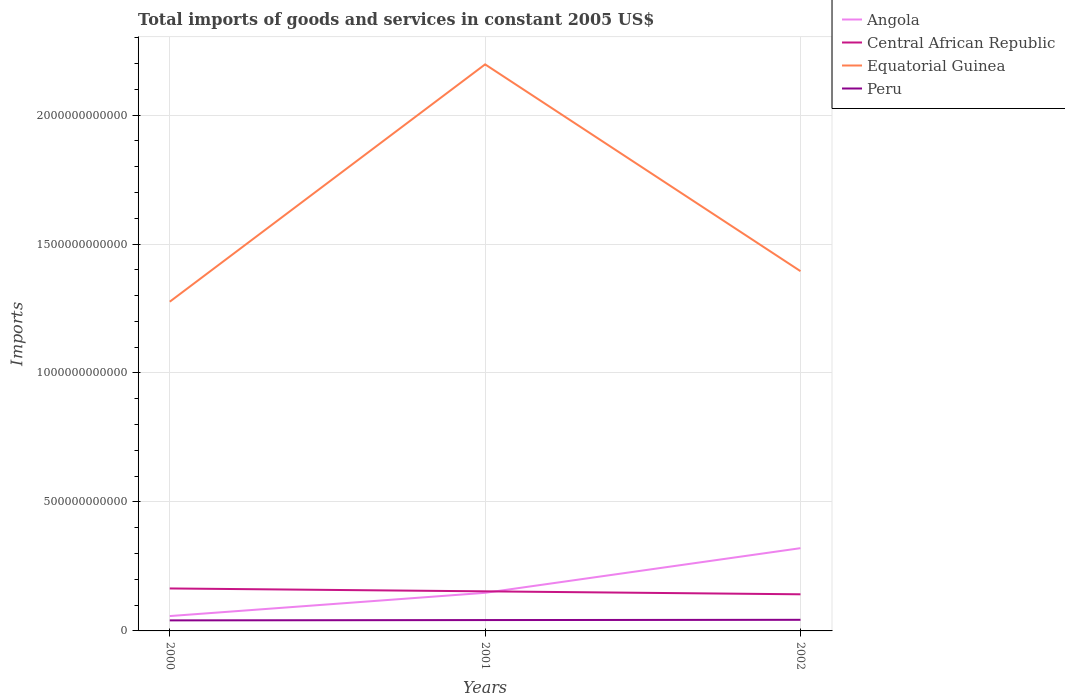How many different coloured lines are there?
Offer a very short reply. 4. Does the line corresponding to Angola intersect with the line corresponding to Equatorial Guinea?
Offer a very short reply. No. Across all years, what is the maximum total imports of goods and services in Peru?
Provide a short and direct response. 4.09e+1. In which year was the total imports of goods and services in Equatorial Guinea maximum?
Keep it short and to the point. 2000. What is the total total imports of goods and services in Central African Republic in the graph?
Your response must be concise. 1.15e+1. What is the difference between the highest and the second highest total imports of goods and services in Angola?
Your answer should be compact. 2.63e+11. Is the total imports of goods and services in Equatorial Guinea strictly greater than the total imports of goods and services in Peru over the years?
Ensure brevity in your answer.  No. How many lines are there?
Your answer should be very brief. 4. How many years are there in the graph?
Your response must be concise. 3. What is the difference between two consecutive major ticks on the Y-axis?
Your response must be concise. 5.00e+11. Are the values on the major ticks of Y-axis written in scientific E-notation?
Your answer should be compact. No. Where does the legend appear in the graph?
Your answer should be compact. Top right. How many legend labels are there?
Offer a very short reply. 4. What is the title of the graph?
Your answer should be compact. Total imports of goods and services in constant 2005 US$. Does "American Samoa" appear as one of the legend labels in the graph?
Ensure brevity in your answer.  No. What is the label or title of the X-axis?
Offer a very short reply. Years. What is the label or title of the Y-axis?
Your response must be concise. Imports. What is the Imports of Angola in 2000?
Give a very brief answer. 5.76e+1. What is the Imports in Central African Republic in 2000?
Your response must be concise. 1.65e+11. What is the Imports in Equatorial Guinea in 2000?
Your answer should be compact. 1.28e+12. What is the Imports of Peru in 2000?
Offer a very short reply. 4.09e+1. What is the Imports of Angola in 2001?
Keep it short and to the point. 1.48e+11. What is the Imports in Central African Republic in 2001?
Your response must be concise. 1.54e+11. What is the Imports of Equatorial Guinea in 2001?
Make the answer very short. 2.20e+12. What is the Imports in Peru in 2001?
Provide a succinct answer. 4.21e+1. What is the Imports in Angola in 2002?
Ensure brevity in your answer.  3.21e+11. What is the Imports in Central African Republic in 2002?
Provide a succinct answer. 1.42e+11. What is the Imports of Equatorial Guinea in 2002?
Your answer should be compact. 1.39e+12. What is the Imports of Peru in 2002?
Give a very brief answer. 4.30e+1. Across all years, what is the maximum Imports in Angola?
Offer a terse response. 3.21e+11. Across all years, what is the maximum Imports in Central African Republic?
Offer a very short reply. 1.65e+11. Across all years, what is the maximum Imports in Equatorial Guinea?
Give a very brief answer. 2.20e+12. Across all years, what is the maximum Imports of Peru?
Your answer should be very brief. 4.30e+1. Across all years, what is the minimum Imports of Angola?
Make the answer very short. 5.76e+1. Across all years, what is the minimum Imports in Central African Republic?
Provide a short and direct response. 1.42e+11. Across all years, what is the minimum Imports of Equatorial Guinea?
Provide a succinct answer. 1.28e+12. Across all years, what is the minimum Imports in Peru?
Offer a very short reply. 4.09e+1. What is the total Imports of Angola in the graph?
Offer a very short reply. 5.26e+11. What is the total Imports in Central African Republic in the graph?
Your answer should be very brief. 4.60e+11. What is the total Imports of Equatorial Guinea in the graph?
Your answer should be compact. 4.87e+12. What is the total Imports of Peru in the graph?
Provide a short and direct response. 1.26e+11. What is the difference between the Imports in Angola in 2000 and that in 2001?
Provide a succinct answer. -9.01e+1. What is the difference between the Imports in Central African Republic in 2000 and that in 2001?
Provide a short and direct response. 1.11e+1. What is the difference between the Imports of Equatorial Guinea in 2000 and that in 2001?
Your answer should be very brief. -9.20e+11. What is the difference between the Imports of Peru in 2000 and that in 2001?
Make the answer very short. -1.18e+09. What is the difference between the Imports of Angola in 2000 and that in 2002?
Give a very brief answer. -2.63e+11. What is the difference between the Imports of Central African Republic in 2000 and that in 2002?
Your answer should be compact. 2.27e+1. What is the difference between the Imports of Equatorial Guinea in 2000 and that in 2002?
Your answer should be very brief. -1.18e+11. What is the difference between the Imports of Peru in 2000 and that in 2002?
Your answer should be very brief. -2.16e+09. What is the difference between the Imports in Angola in 2001 and that in 2002?
Make the answer very short. -1.73e+11. What is the difference between the Imports in Central African Republic in 2001 and that in 2002?
Ensure brevity in your answer.  1.15e+1. What is the difference between the Imports in Equatorial Guinea in 2001 and that in 2002?
Your response must be concise. 8.02e+11. What is the difference between the Imports in Peru in 2001 and that in 2002?
Ensure brevity in your answer.  -9.76e+08. What is the difference between the Imports of Angola in 2000 and the Imports of Central African Republic in 2001?
Keep it short and to the point. -9.59e+1. What is the difference between the Imports of Angola in 2000 and the Imports of Equatorial Guinea in 2001?
Provide a short and direct response. -2.14e+12. What is the difference between the Imports in Angola in 2000 and the Imports in Peru in 2001?
Offer a very short reply. 1.55e+1. What is the difference between the Imports of Central African Republic in 2000 and the Imports of Equatorial Guinea in 2001?
Give a very brief answer. -2.03e+12. What is the difference between the Imports of Central African Republic in 2000 and the Imports of Peru in 2001?
Keep it short and to the point. 1.23e+11. What is the difference between the Imports in Equatorial Guinea in 2000 and the Imports in Peru in 2001?
Your answer should be compact. 1.23e+12. What is the difference between the Imports in Angola in 2000 and the Imports in Central African Republic in 2002?
Keep it short and to the point. -8.44e+1. What is the difference between the Imports in Angola in 2000 and the Imports in Equatorial Guinea in 2002?
Give a very brief answer. -1.34e+12. What is the difference between the Imports of Angola in 2000 and the Imports of Peru in 2002?
Your answer should be compact. 1.45e+1. What is the difference between the Imports of Central African Republic in 2000 and the Imports of Equatorial Guinea in 2002?
Ensure brevity in your answer.  -1.23e+12. What is the difference between the Imports in Central African Republic in 2000 and the Imports in Peru in 2002?
Your answer should be very brief. 1.22e+11. What is the difference between the Imports of Equatorial Guinea in 2000 and the Imports of Peru in 2002?
Make the answer very short. 1.23e+12. What is the difference between the Imports of Angola in 2001 and the Imports of Central African Republic in 2002?
Your response must be concise. 5.74e+09. What is the difference between the Imports of Angola in 2001 and the Imports of Equatorial Guinea in 2002?
Your answer should be compact. -1.25e+12. What is the difference between the Imports in Angola in 2001 and the Imports in Peru in 2002?
Offer a very short reply. 1.05e+11. What is the difference between the Imports of Central African Republic in 2001 and the Imports of Equatorial Guinea in 2002?
Provide a short and direct response. -1.24e+12. What is the difference between the Imports in Central African Republic in 2001 and the Imports in Peru in 2002?
Keep it short and to the point. 1.10e+11. What is the difference between the Imports of Equatorial Guinea in 2001 and the Imports of Peru in 2002?
Offer a very short reply. 2.15e+12. What is the average Imports in Angola per year?
Give a very brief answer. 1.75e+11. What is the average Imports of Central African Republic per year?
Make the answer very short. 1.53e+11. What is the average Imports in Equatorial Guinea per year?
Give a very brief answer. 1.62e+12. What is the average Imports of Peru per year?
Ensure brevity in your answer.  4.20e+1. In the year 2000, what is the difference between the Imports of Angola and Imports of Central African Republic?
Your response must be concise. -1.07e+11. In the year 2000, what is the difference between the Imports of Angola and Imports of Equatorial Guinea?
Offer a very short reply. -1.22e+12. In the year 2000, what is the difference between the Imports in Angola and Imports in Peru?
Your answer should be compact. 1.67e+1. In the year 2000, what is the difference between the Imports in Central African Republic and Imports in Equatorial Guinea?
Give a very brief answer. -1.11e+12. In the year 2000, what is the difference between the Imports in Central African Republic and Imports in Peru?
Your answer should be very brief. 1.24e+11. In the year 2000, what is the difference between the Imports in Equatorial Guinea and Imports in Peru?
Give a very brief answer. 1.24e+12. In the year 2001, what is the difference between the Imports in Angola and Imports in Central African Republic?
Make the answer very short. -5.79e+09. In the year 2001, what is the difference between the Imports in Angola and Imports in Equatorial Guinea?
Offer a very short reply. -2.05e+12. In the year 2001, what is the difference between the Imports of Angola and Imports of Peru?
Your answer should be compact. 1.06e+11. In the year 2001, what is the difference between the Imports in Central African Republic and Imports in Equatorial Guinea?
Keep it short and to the point. -2.04e+12. In the year 2001, what is the difference between the Imports of Central African Republic and Imports of Peru?
Keep it short and to the point. 1.11e+11. In the year 2001, what is the difference between the Imports in Equatorial Guinea and Imports in Peru?
Provide a short and direct response. 2.15e+12. In the year 2002, what is the difference between the Imports in Angola and Imports in Central African Republic?
Ensure brevity in your answer.  1.79e+11. In the year 2002, what is the difference between the Imports of Angola and Imports of Equatorial Guinea?
Offer a terse response. -1.07e+12. In the year 2002, what is the difference between the Imports of Angola and Imports of Peru?
Your answer should be very brief. 2.78e+11. In the year 2002, what is the difference between the Imports of Central African Republic and Imports of Equatorial Guinea?
Offer a very short reply. -1.25e+12. In the year 2002, what is the difference between the Imports of Central African Republic and Imports of Peru?
Offer a very short reply. 9.89e+1. In the year 2002, what is the difference between the Imports of Equatorial Guinea and Imports of Peru?
Your response must be concise. 1.35e+12. What is the ratio of the Imports of Angola in 2000 to that in 2001?
Make the answer very short. 0.39. What is the ratio of the Imports of Central African Republic in 2000 to that in 2001?
Provide a short and direct response. 1.07. What is the ratio of the Imports of Equatorial Guinea in 2000 to that in 2001?
Provide a short and direct response. 0.58. What is the ratio of the Imports of Peru in 2000 to that in 2001?
Make the answer very short. 0.97. What is the ratio of the Imports of Angola in 2000 to that in 2002?
Ensure brevity in your answer.  0.18. What is the ratio of the Imports of Central African Republic in 2000 to that in 2002?
Provide a succinct answer. 1.16. What is the ratio of the Imports of Equatorial Guinea in 2000 to that in 2002?
Your response must be concise. 0.92. What is the ratio of the Imports in Peru in 2000 to that in 2002?
Offer a very short reply. 0.95. What is the ratio of the Imports in Angola in 2001 to that in 2002?
Give a very brief answer. 0.46. What is the ratio of the Imports in Central African Republic in 2001 to that in 2002?
Offer a terse response. 1.08. What is the ratio of the Imports in Equatorial Guinea in 2001 to that in 2002?
Make the answer very short. 1.57. What is the ratio of the Imports in Peru in 2001 to that in 2002?
Give a very brief answer. 0.98. What is the difference between the highest and the second highest Imports in Angola?
Keep it short and to the point. 1.73e+11. What is the difference between the highest and the second highest Imports in Central African Republic?
Offer a very short reply. 1.11e+1. What is the difference between the highest and the second highest Imports in Equatorial Guinea?
Give a very brief answer. 8.02e+11. What is the difference between the highest and the second highest Imports in Peru?
Offer a terse response. 9.76e+08. What is the difference between the highest and the lowest Imports in Angola?
Offer a terse response. 2.63e+11. What is the difference between the highest and the lowest Imports in Central African Republic?
Offer a very short reply. 2.27e+1. What is the difference between the highest and the lowest Imports of Equatorial Guinea?
Provide a succinct answer. 9.20e+11. What is the difference between the highest and the lowest Imports of Peru?
Your answer should be compact. 2.16e+09. 